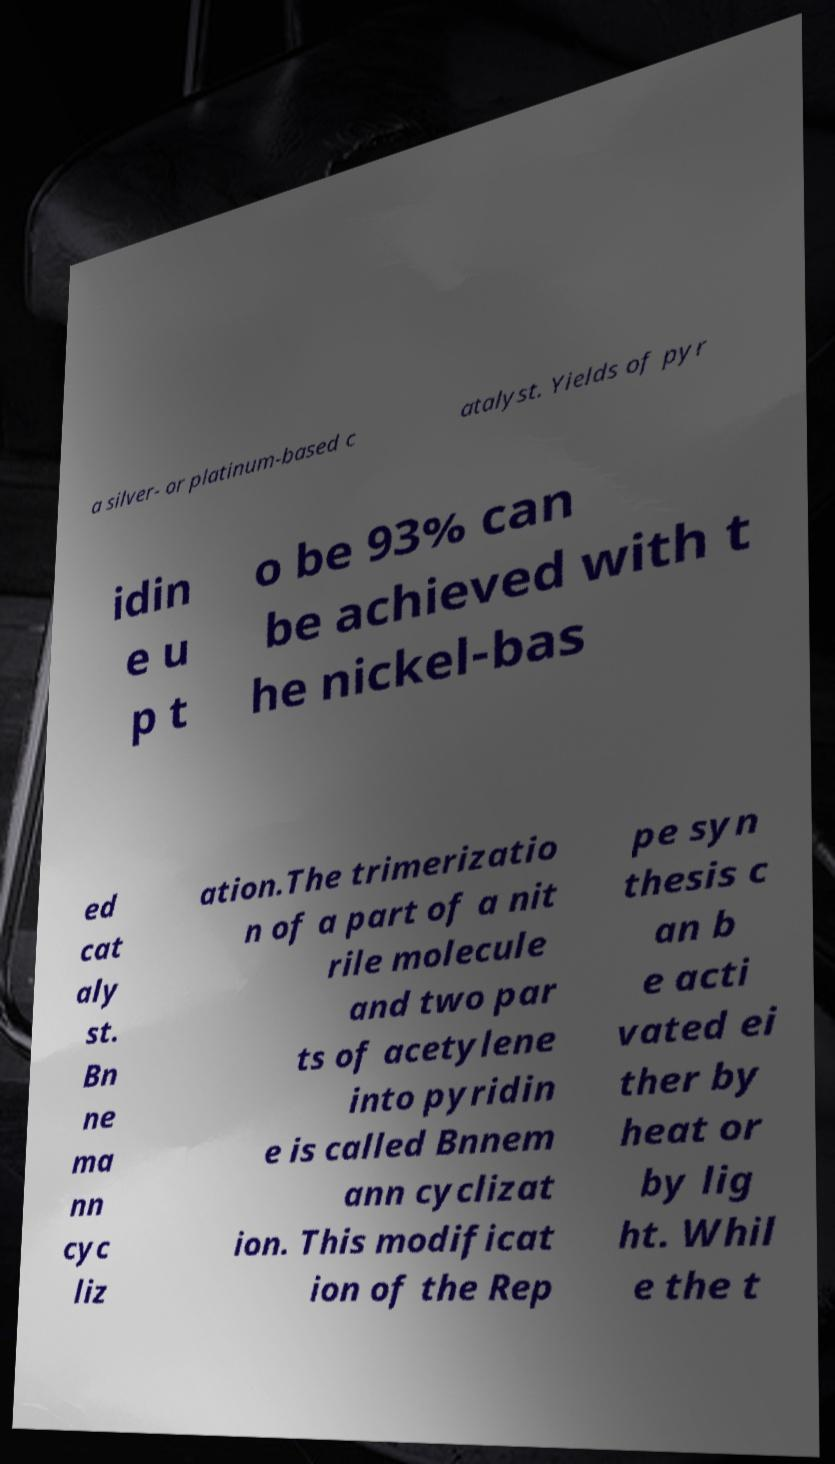What messages or text are displayed in this image? I need them in a readable, typed format. a silver- or platinum-based c atalyst. Yields of pyr idin e u p t o be 93% can be achieved with t he nickel-bas ed cat aly st. Bn ne ma nn cyc liz ation.The trimerizatio n of a part of a nit rile molecule and two par ts of acetylene into pyridin e is called Bnnem ann cyclizat ion. This modificat ion of the Rep pe syn thesis c an b e acti vated ei ther by heat or by lig ht. Whil e the t 